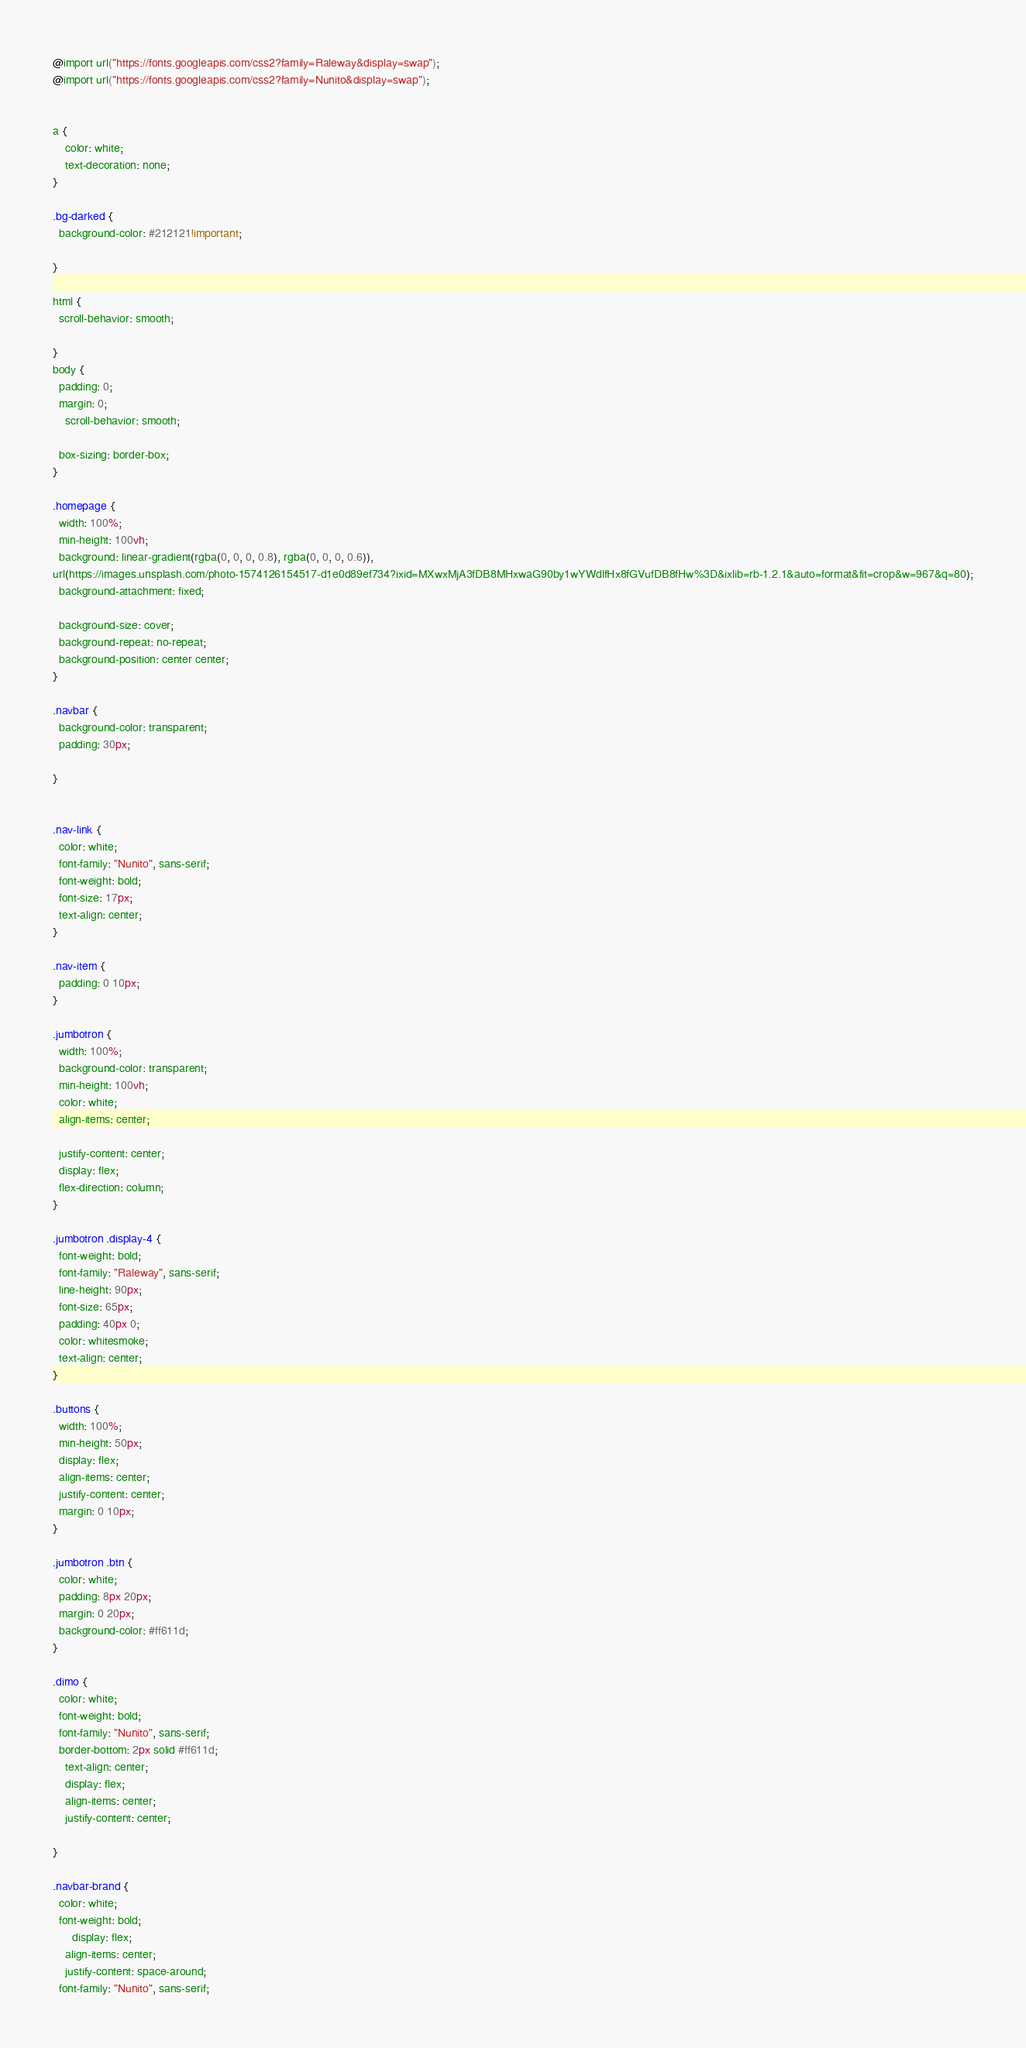<code> <loc_0><loc_0><loc_500><loc_500><_CSS_>@import url("https://fonts.googleapis.com/css2?family=Raleway&display=swap");
@import url("https://fonts.googleapis.com/css2?family=Nunito&display=swap");


a {
	color: white;
	text-decoration: none;
}

.bg-darked {
  background-color: #212121!important;

}

html {
  scroll-behavior: smooth;

}
body {
  padding: 0;
  margin: 0;
    scroll-behavior: smooth;

  box-sizing: border-box;
}

.homepage {
  width: 100%;
  min-height: 100vh;
  background: linear-gradient(rgba(0, 0, 0, 0.8), rgba(0, 0, 0, 0.6)),
url(https://images.unsplash.com/photo-1574126154517-d1e0d89ef734?ixid=MXwxMjA3fDB8MHxwaG90by1wYWdlfHx8fGVufDB8fHw%3D&ixlib=rb-1.2.1&auto=format&fit=crop&w=967&q=80);
  background-attachment: fixed;

  background-size: cover;
  background-repeat: no-repeat;
  background-position: center center;
}

.navbar {
  background-color: transparent;
  padding: 30px;

}


.nav-link {
  color: white;
  font-family: "Nunito", sans-serif;
  font-weight: bold;
  font-size: 17px;
  text-align: center;
}

.nav-item {
  padding: 0 10px;
}

.jumbotron {
  width: 100%;
  background-color: transparent;
  min-height: 100vh;
  color: white;
  align-items: center;

  justify-content: center;
  display: flex;
  flex-direction: column;
}

.jumbotron .display-4 {
  font-weight: bold;
  font-family: "Raleway", sans-serif;
  line-height: 90px;
  font-size: 65px;
  padding: 40px 0;
  color: whitesmoke;
  text-align: center;
}

.buttons {
  width: 100%;
  min-height: 50px;
  display: flex;
  align-items: center;
  justify-content: center;
  margin: 0 10px;
}

.jumbotron .btn {
  color: white;
  padding: 8px 20px;
  margin: 0 20px;
  background-color: #ff611d;
}

.dimo {
  color: white;
  font-weight: bold;
  font-family: "Nunito", sans-serif;
  border-bottom: 2px solid #ff611d;
    text-align: center;
    display: flex;
    align-items: center;
    justify-content: center;

}

.navbar-brand {
  color: white;
  font-weight: bold;
      display: flex;
    align-items: center;
    justify-content: space-around;
  font-family: "Nunito", sans-serif;</code> 